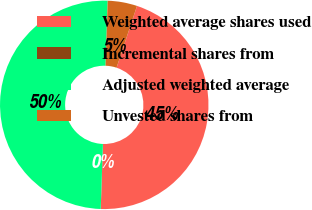<chart> <loc_0><loc_0><loc_500><loc_500><pie_chart><fcel>Weighted average shares used<fcel>Incremental shares from<fcel>Adjusted weighted average<fcel>Unvested shares from<nl><fcel>45.44%<fcel>0.01%<fcel>49.99%<fcel>4.56%<nl></chart> 